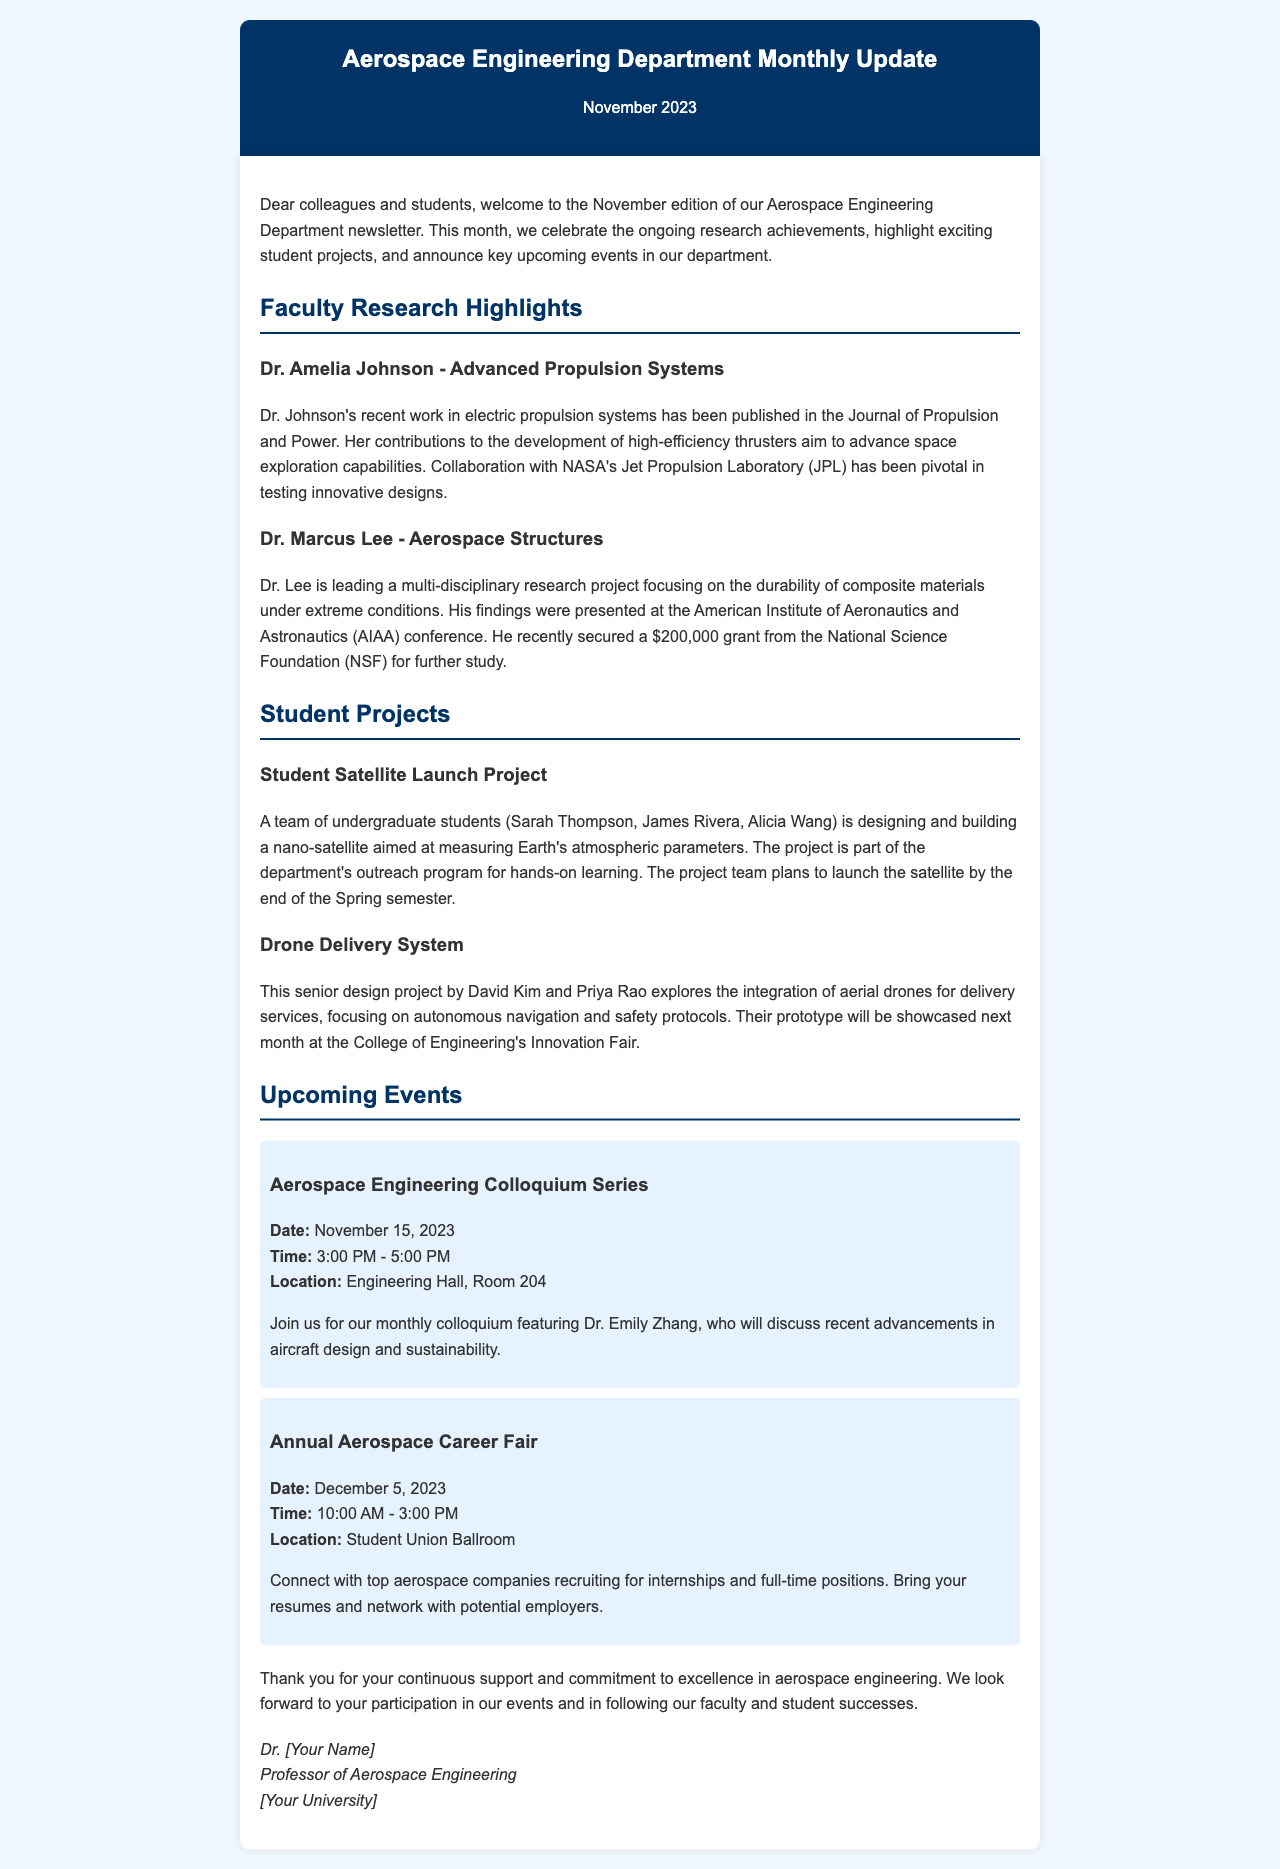What is the title of the newsletter? The title of the newsletter is mentioned at the top of the document.
Answer: Aerospace Engineering Department Monthly Update Who is featured in the faculty research section? The names of the faculty members and their research topics are mentioned in the document.
Answer: Dr. Amelia Johnson and Dr. Marcus Lee What is the project aimed at measuring? The purpose of the Student Satellite Launch Project is indicated in the description of the project.
Answer: Earth's atmospheric parameters When is the Aerospace Engineering Colloquium Series scheduled? The specific date for the event is provided in the upcoming events section.
Answer: November 15, 2023 What type of project is David Kim working on? The document describes the nature of David Kim's project.
Answer: Drone Delivery System What funding amount did Dr. Lee secure for his research? The document specifies the grant amount Dr. Lee received.
Answer: $200,000 What is the location of the Annual Aerospace Career Fair? The location for the event is stated clearly in the upcoming events section of the document.
Answer: Student Union Ballroom Who will be speaking at the colloquium? The name of the speaker for the colloquium is mentioned in the event details.
Answer: Dr. Emily Zhang 